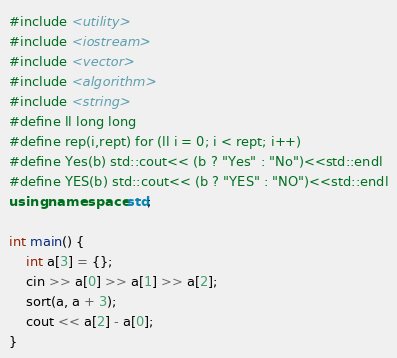<code> <loc_0><loc_0><loc_500><loc_500><_C++_>#include <utility>
#include <iostream>
#include <vector>
#include <algorithm>
#include <string>
#define ll long long
#define rep(i,rept) for (ll i = 0; i < rept; i++)
#define Yes(b) std::cout<< (b ? "Yes" : "No")<<std::endl
#define YES(b) std::cout<< (b ? "YES" : "NO")<<std::endl
using namespace std;

int main() {
	int a[3] = {};
	cin >> a[0] >> a[1] >> a[2];
	sort(a, a + 3);
	cout << a[2] - a[0];
}
</code> 